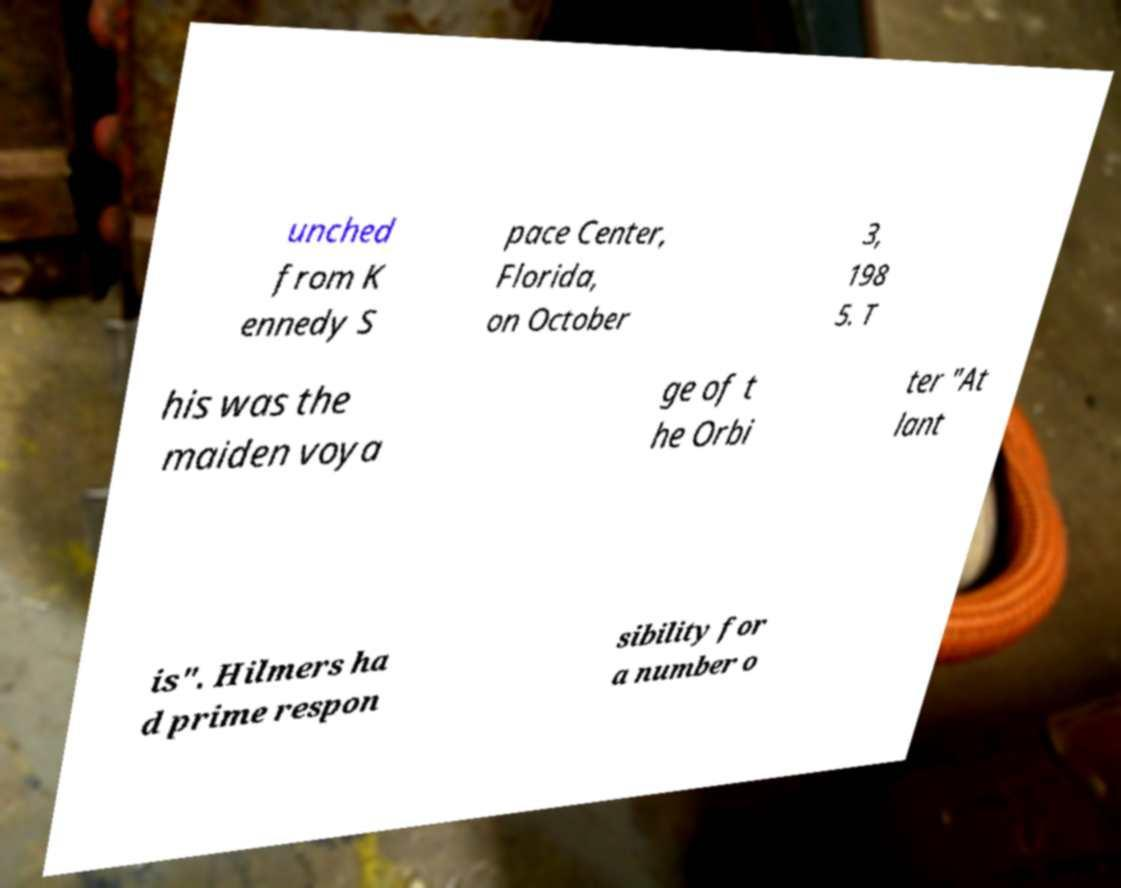I need the written content from this picture converted into text. Can you do that? unched from K ennedy S pace Center, Florida, on October 3, 198 5. T his was the maiden voya ge of t he Orbi ter "At lant is". Hilmers ha d prime respon sibility for a number o 